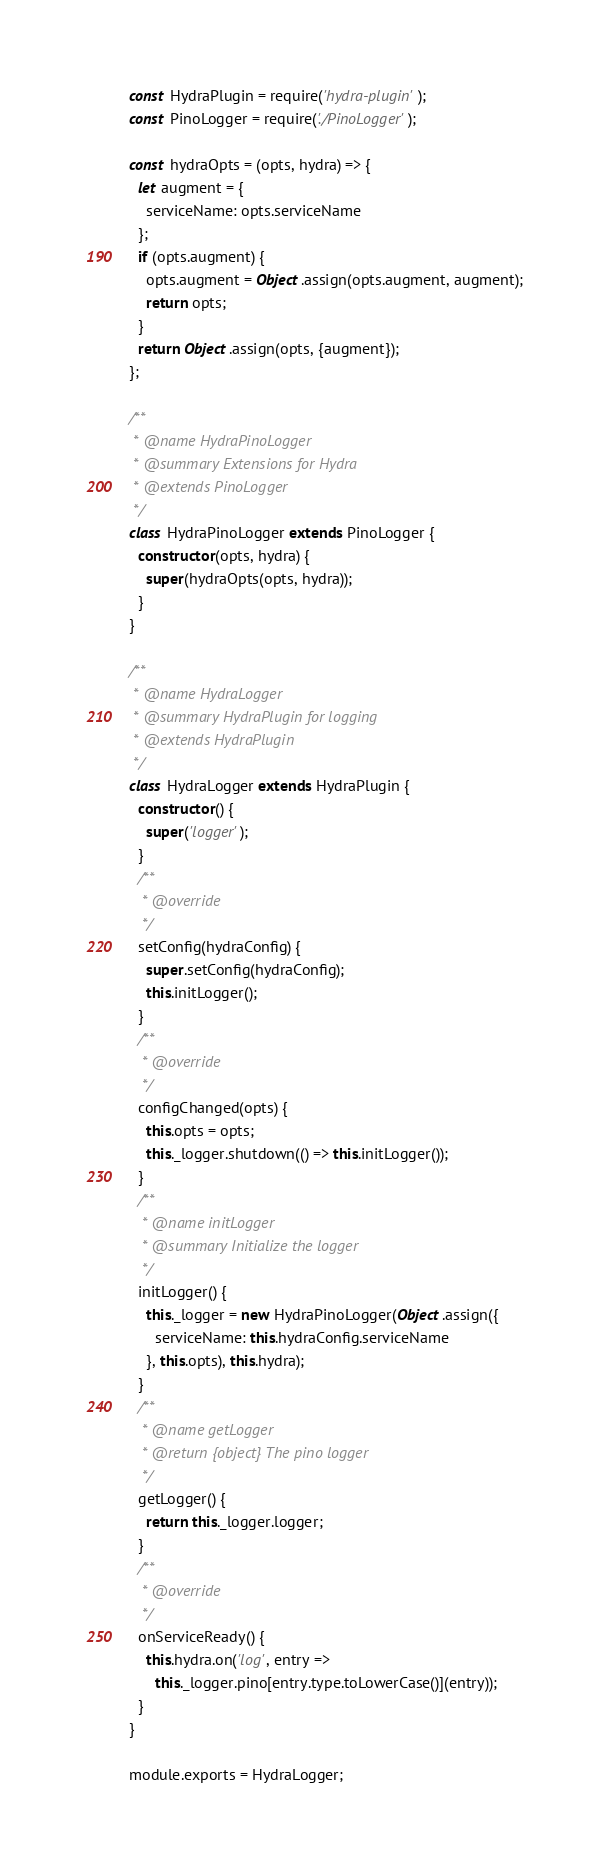<code> <loc_0><loc_0><loc_500><loc_500><_JavaScript_>
const HydraPlugin = require('hydra-plugin');
const PinoLogger = require('./PinoLogger');

const hydraOpts = (opts, hydra) => {
  let augment = {
    serviceName: opts.serviceName
  };
  if (opts.augment) {
    opts.augment = Object.assign(opts.augment, augment);
    return opts;
  }
  return Object.assign(opts, {augment});
};

/**
 * @name HydraPinoLogger
 * @summary Extensions for Hydra
 * @extends PinoLogger
 */
class HydraPinoLogger extends PinoLogger {
  constructor(opts, hydra) {
    super(hydraOpts(opts, hydra));
  }
}

/**
 * @name HydraLogger
 * @summary HydraPlugin for logging
 * @extends HydraPlugin
 */
class HydraLogger extends HydraPlugin {
  constructor() {
    super('logger');
  }
  /**
   * @override
   */
  setConfig(hydraConfig) {
    super.setConfig(hydraConfig);
    this.initLogger();
  }
  /**
   * @override
   */
  configChanged(opts) {
    this.opts = opts;
    this._logger.shutdown(() => this.initLogger());
  }
  /**
   * @name initLogger
   * @summary Initialize the logger
   */
  initLogger() {
    this._logger = new HydraPinoLogger(Object.assign({
      serviceName: this.hydraConfig.serviceName
    }, this.opts), this.hydra);
  }
  /**
   * @name getLogger
   * @return {object} The pino logger
   */
  getLogger() {
    return this._logger.logger;
  }
  /**
   * @override
   */
  onServiceReady() {
    this.hydra.on('log', entry =>
      this._logger.pino[entry.type.toLowerCase()](entry));
  }
}

module.exports = HydraLogger;
</code> 